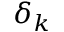Convert formula to latex. <formula><loc_0><loc_0><loc_500><loc_500>\delta _ { k }</formula> 